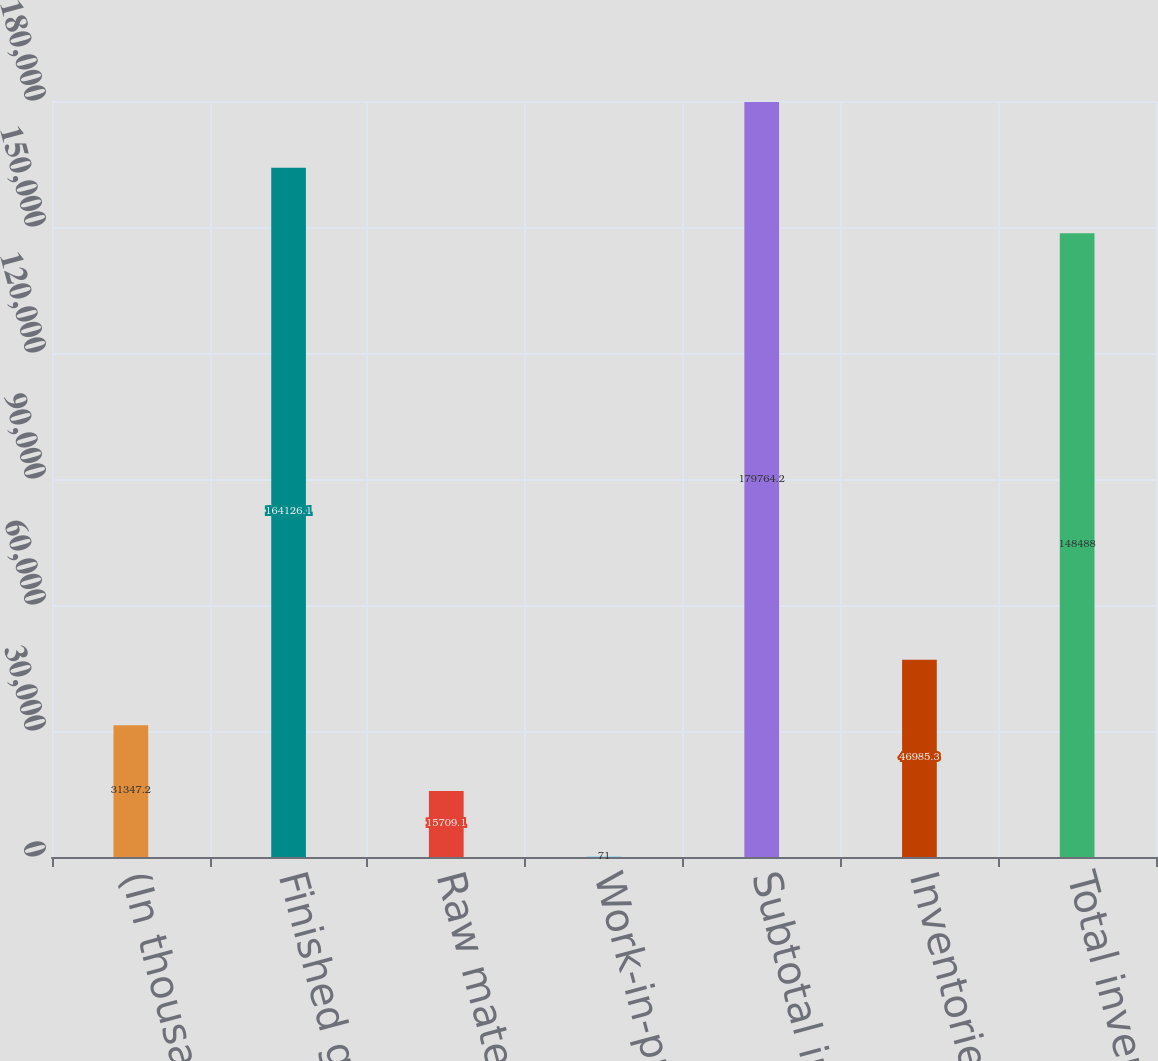Convert chart. <chart><loc_0><loc_0><loc_500><loc_500><bar_chart><fcel>(In thousands)<fcel>Finished goods<fcel>Raw materials<fcel>Work-in-process<fcel>Subtotal inventories<fcel>Inventories reserve<fcel>Total inventories<nl><fcel>31347.2<fcel>164126<fcel>15709.1<fcel>71<fcel>179764<fcel>46985.3<fcel>148488<nl></chart> 